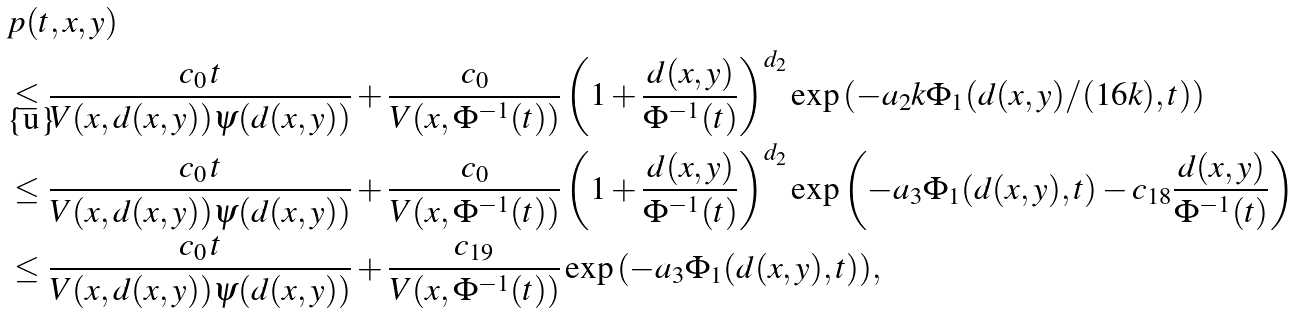<formula> <loc_0><loc_0><loc_500><loc_500>& p ( t , x , y ) \\ & \leq \frac { c _ { 0 } \, t } { V ( x , d ( x , y ) ) \psi ( d ( x , y ) ) } + \frac { c _ { 0 } } { V ( x , \Phi ^ { - 1 } ( t ) ) } \left ( 1 + \frac { d ( x , y ) } { \Phi ^ { - 1 } ( t ) } \right ) ^ { d _ { 2 } } \exp { \left ( - a _ { 2 } k \Phi _ { 1 } ( d ( x , y ) / ( 1 6 k ) , t ) \right ) } \\ & \leq \frac { c _ { 0 } \, t } { V ( x , d ( x , y ) ) \psi ( d ( x , y ) ) } + \frac { c _ { 0 } } { V ( x , \Phi ^ { - 1 } ( t ) ) } \left ( 1 + \frac { d ( x , y ) } { \Phi ^ { - 1 } ( t ) } \right ) ^ { d _ { 2 } } \exp { \left ( - a _ { 3 } \Phi _ { 1 } ( d ( x , y ) , t ) - c _ { 1 8 } \frac { d ( x , y ) } { \Phi ^ { - 1 } ( t ) } \right ) } \\ & \leq \frac { c _ { 0 } \, t } { V ( x , d ( x , y ) ) \psi ( d ( x , y ) ) } + \frac { c _ { 1 9 } } { V ( x , \Phi ^ { - 1 } ( t ) ) } \exp { \left ( - a _ { 3 } \Phi _ { 1 } ( d ( x , y ) , t ) \right ) } ,</formula> 